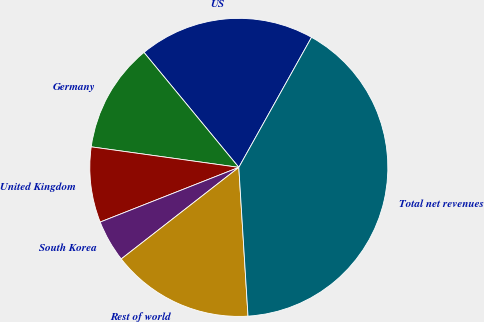Convert chart. <chart><loc_0><loc_0><loc_500><loc_500><pie_chart><fcel>US<fcel>Germany<fcel>United Kingdom<fcel>South Korea<fcel>Rest of world<fcel>Total net revenues<nl><fcel>19.09%<fcel>11.82%<fcel>8.18%<fcel>4.55%<fcel>15.45%<fcel>40.9%<nl></chart> 